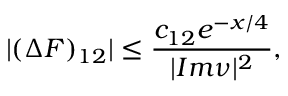Convert formula to latex. <formula><loc_0><loc_0><loc_500><loc_500>| ( \Delta F ) _ { 1 2 } | \leq \frac { c _ { 1 2 } e ^ { - x / 4 } } { | I m \nu | ^ { 2 } } ,</formula> 